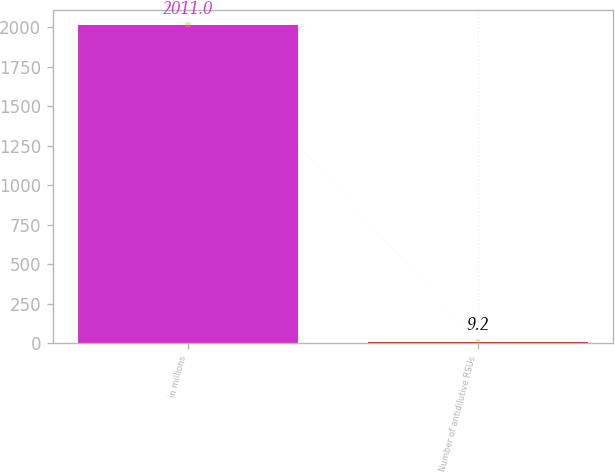Convert chart to OTSL. <chart><loc_0><loc_0><loc_500><loc_500><bar_chart><fcel>in millions<fcel>Number of antidilutive RSUs<nl><fcel>2011<fcel>9.2<nl></chart> 